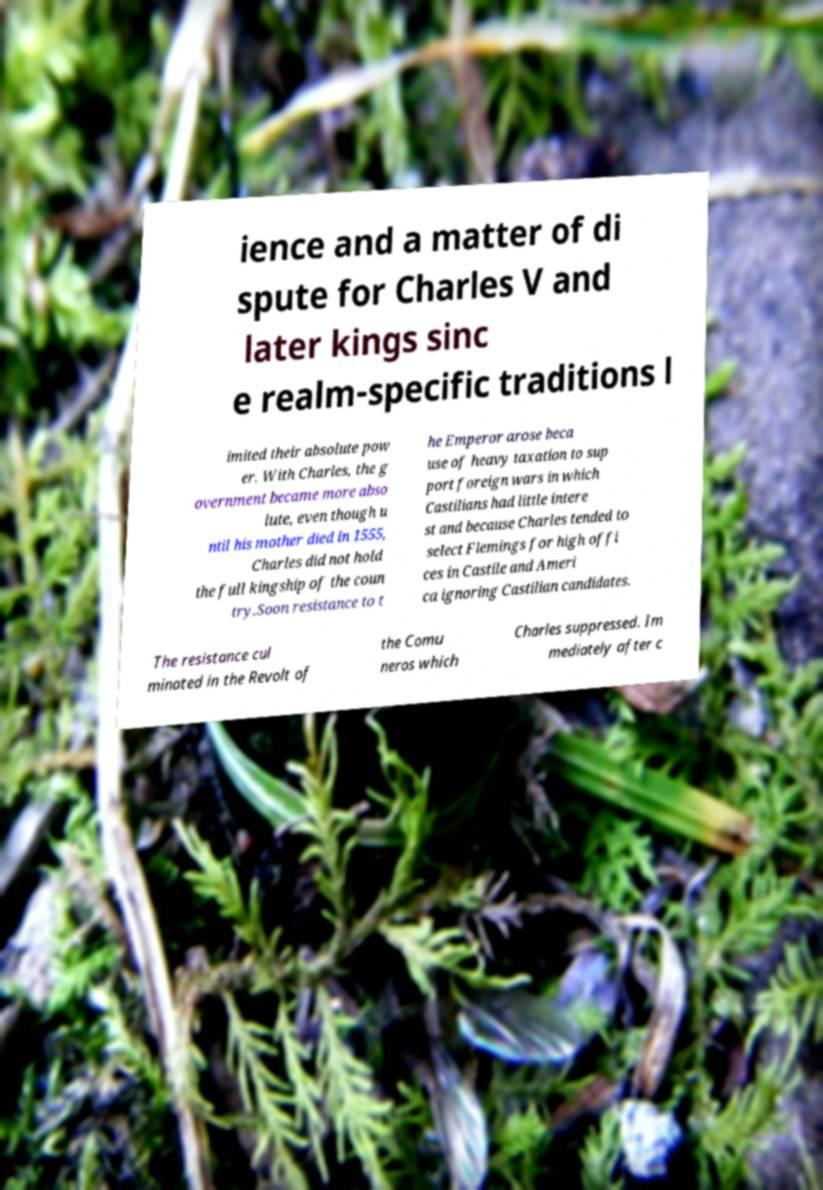What messages or text are displayed in this image? I need them in a readable, typed format. ience and a matter of di spute for Charles V and later kings sinc e realm-specific traditions l imited their absolute pow er. With Charles, the g overnment became more abso lute, even though u ntil his mother died in 1555, Charles did not hold the full kingship of the coun try.Soon resistance to t he Emperor arose beca use of heavy taxation to sup port foreign wars in which Castilians had little intere st and because Charles tended to select Flemings for high offi ces in Castile and Ameri ca ignoring Castilian candidates. The resistance cul minated in the Revolt of the Comu neros which Charles suppressed. Im mediately after c 